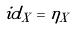<formula> <loc_0><loc_0><loc_500><loc_500>i d _ { X } = \eta _ { X }</formula> 